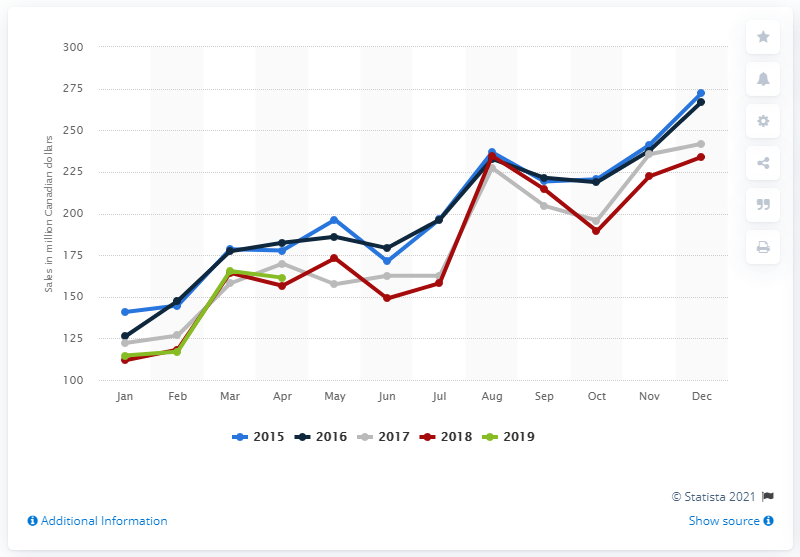Point out several critical features in this image. According to the data provided, the monthly sales of girls', boys' and infants' clothing and accessories at large retailers in Canada in April 2019 were CAD 162.59. 